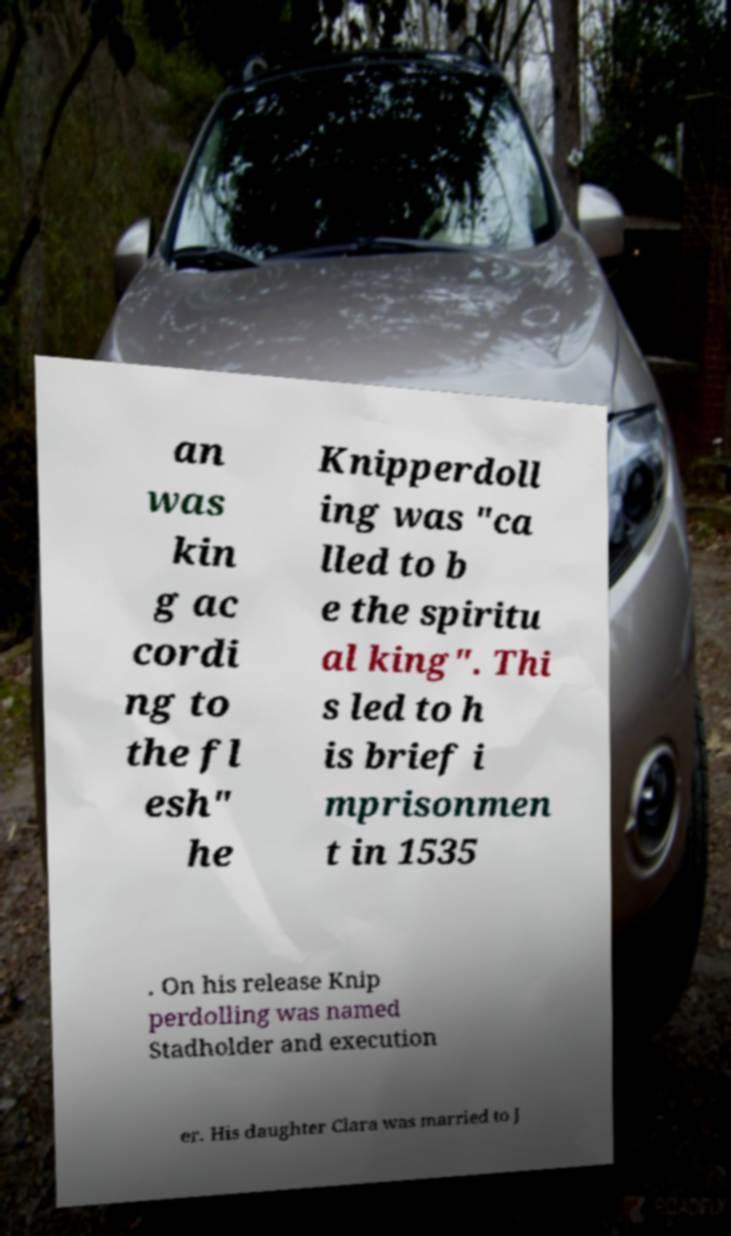There's text embedded in this image that I need extracted. Can you transcribe it verbatim? an was kin g ac cordi ng to the fl esh" he Knipperdoll ing was "ca lled to b e the spiritu al king". Thi s led to h is brief i mprisonmen t in 1535 . On his release Knip perdolling was named Stadholder and execution er. His daughter Clara was married to J 